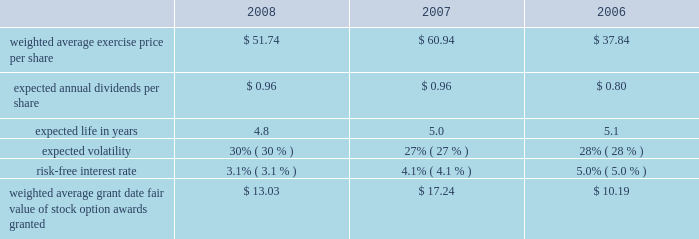Marathon oil corporation notes to consolidated financial statements stock appreciation rights 2013 prior to 2005 , we granted sars under the 2003 plan .
No stock appreciation rights have been granted under the 2007 plan .
Similar to stock options , stock appreciation rights represent the right to receive a payment equal to the excess of the fair market value of shares of common stock on the date the right is exercised over the grant price .
Under the 2003 plan , certain sars were granted as stock-settled sars and others were granted in tandem with stock options .
In general , sars granted under the 2003 plan vest ratably over a three-year period and have a maximum term of ten years from the date they are granted .
Stock-based performance awards 2013 prior to 2005 , we granted stock-based performance awards under the 2003 plan .
No stock-based performance awards have been granted under the 2007 plan .
Beginning in 2005 , we discontinued granting stock-based performance awards and instead now grant cash-settled performance units to officers .
All stock-based performance awards granted under the 2003 plan have either vested or been forfeited .
As a result , there are no outstanding stock-based performance awards .
Restricted stock 2013 we grant restricted stock and restricted stock units under the 2007 plan and previously granted such awards under the 2003 plan .
In 2005 , the compensation committee began granting time-based restricted stock to certain u.s.-based officers of marathon and its consolidated subsidiaries as part of their annual long-term incentive package .
The restricted stock awards to officers vest three years from the date of grant , contingent on the recipient 2019s continued employment .
We also grant restricted stock to certain non-officer employees and restricted stock units to certain international employees ( 201crestricted stock awards 201d ) , based on their performance within certain guidelines and for retention purposes .
The restricted stock awards to non-officers generally vest in one-third increments over a three-year period , contingent on the recipient 2019s continued employment , however , certain restricted stock awards granted in 2008 will vest over a four-year period , contingent on the recipient 2019s continued employment .
Prior to vesting , all restricted stock recipients have the right to vote such stock and receive dividends thereon .
The non-vested shares are not transferable and are held by our transfer agent .
Common stock units 2013 we maintain an equity compensation program for our non-employee directors under the 2007 plan and previously maintained such a program under the 2003 plan .
All non-employee directors other than the chairman receive annual grants of common stock units , and they are required to hold those units until they leave the board of directors .
When dividends are paid on marathon common stock , directors receive dividend equivalents in the form of additional common stock units .
Total stock-based compensation expense total employee stock-based compensation expense was $ 43 million , $ 66 million and $ 78 million in 2008 , 2007 and 2006 .
The total related income tax benefits were $ 16 million , $ 24 million and $ 29 million .
In 2008 and 2007 , cash received upon exercise of stock option awards was $ 9 million and $ 27 million .
Tax benefits realized for deductions during 2008 and 2007 that were in excess of the stock-based compensation expense recorded for options exercised and other stock-based awards vested during the period totaled $ 7 million and $ 30 million .
Cash settlements of stock option awards totaled $ 1 million in 2007 .
There were no cash settlements in 2008 .
Stock option awards during 2008 , 2007 and 2006 , we granted stock option awards to both officer and non-officer employees .
The weighted average grant date fair value of these awards was based on the following black-scholes assumptions: .

In 2008 and 2007 , what was total cash received upon exercise of stock option awards in millions? 
Computations: (9 + 27)
Answer: 36.0. 